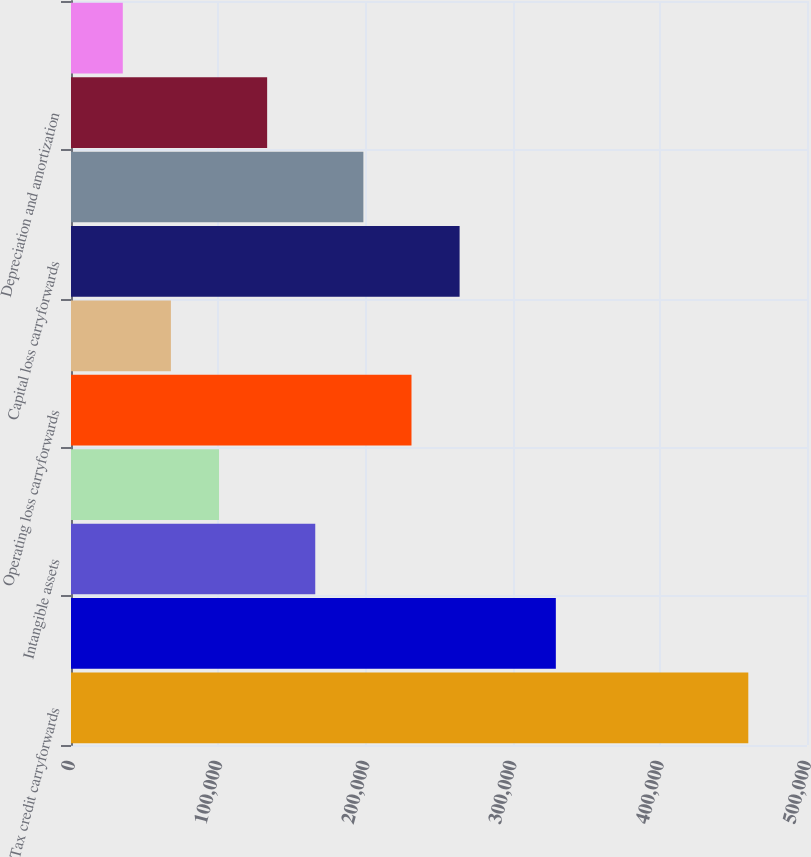Convert chart to OTSL. <chart><loc_0><loc_0><loc_500><loc_500><bar_chart><fcel>Tax credit carryforwards<fcel>Reserves and accruals<fcel>Intangible assets<fcel>Capitalized research and<fcel>Operating loss carryforwards<fcel>Deferred income<fcel>Capital loss carryforwards<fcel>Stock-based compensation costs<fcel>Depreciation and amortization<fcel>Investments<nl><fcel>460125<fcel>329374<fcel>165936<fcel>100560<fcel>231311<fcel>67872.4<fcel>263999<fcel>198623<fcel>133248<fcel>35184.7<nl></chart> 